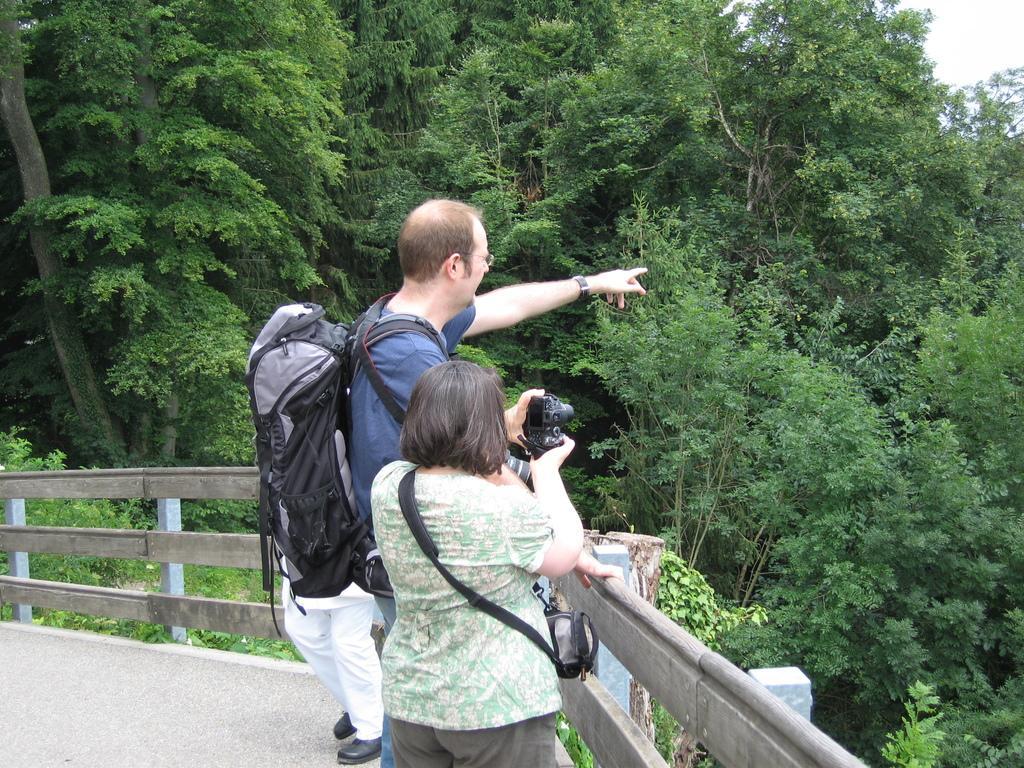Can you describe this image briefly? In the foreground of this image, there is a woman wearing a bag and holding a camera. Behind her, there is a man wearing backpack and also a person are standing near a railing. In the background, there are trees and the sky. 